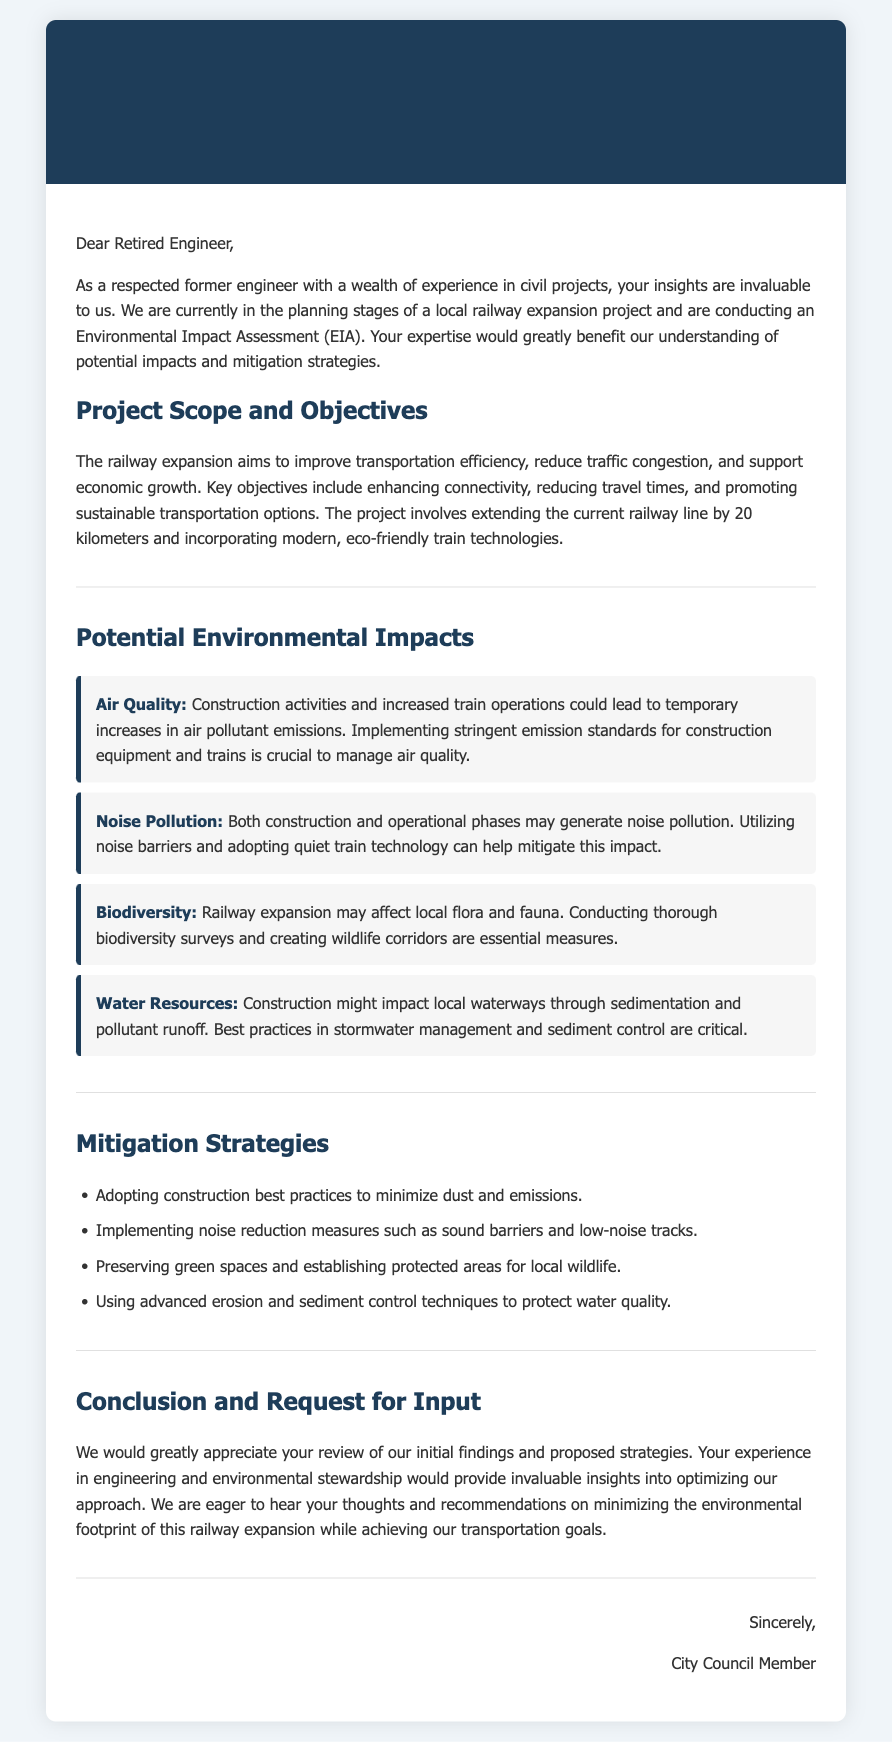What are the key objectives of the railway expansion? The document outlines the key objectives including enhancing connectivity, reducing travel times, and promoting sustainable transportation options.
Answer: enhancing connectivity, reducing travel times, promoting sustainable transportation options How many kilometers is the railway line being extended? The project involves extending the current railway line by 20 kilometers.
Answer: 20 kilometers What type of technology is being incorporated in the railway expansion? The document specifies the incorporation of modern, eco-friendly train technologies.
Answer: eco-friendly train technologies What is one potential environmental impact mentioned in the document? Examples of potential environmental impacts include air quality, noise pollution, biodiversity, and water resources.
Answer: air quality What is one mitigation strategy proposed in the document? The document lists strategies such as adopting construction best practices to minimize dust and emissions.
Answer: adopting construction best practices Who is the intended recipient of the document? The document is addressed to a retired engineer, signifying that the intended recipient is someone with expertise in engineering.
Answer: retired engineer What does the City Council member request at the end of the document? The conclusion of the document includes a request for the retired engineer’s review of the initial findings and proposed strategies.
Answer: review of initial findings and proposed strategies What is the background color of the document? The document has a background color of #f0f5f9, which is a light blue shade.
Answer: #f0f5f9 What color is used for the header background? The header background color is #1e3d59, a dark blue shade.
Answer: #1e3d59 